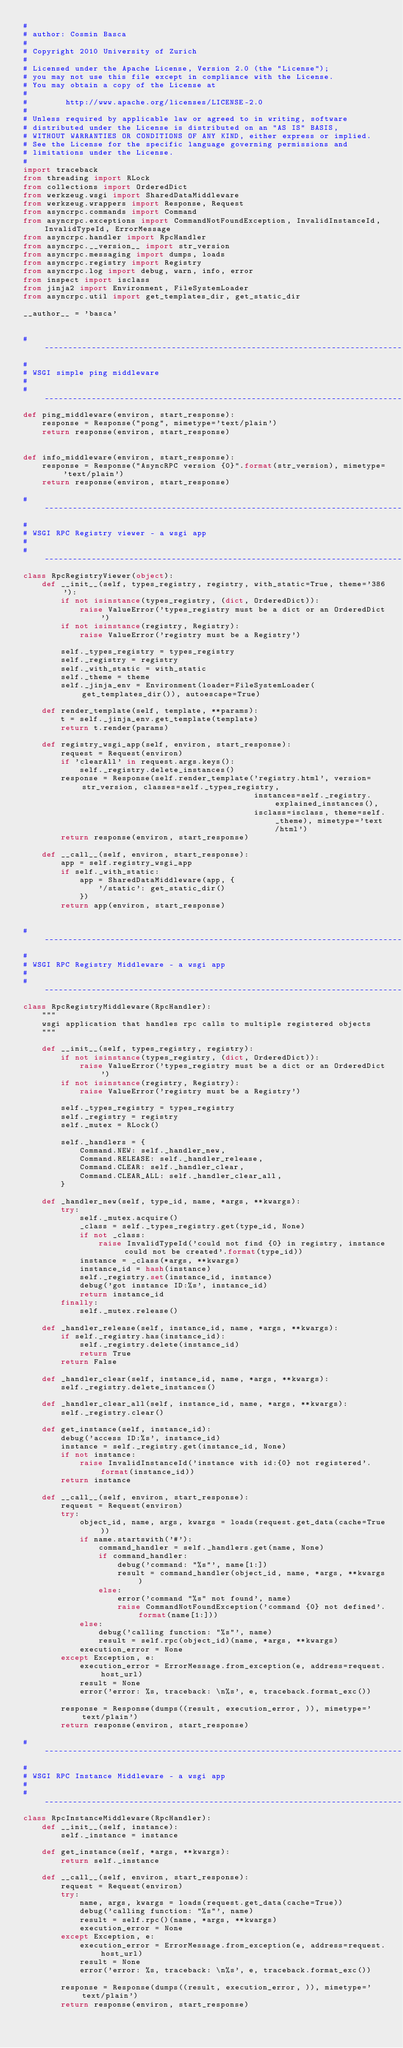<code> <loc_0><loc_0><loc_500><loc_500><_Python_>#
# author: Cosmin Basca
#
# Copyright 2010 University of Zurich
#
# Licensed under the Apache License, Version 2.0 (the "License");
# you may not use this file except in compliance with the License.
# You may obtain a copy of the License at
#
#        http://www.apache.org/licenses/LICENSE-2.0
#
# Unless required by applicable law or agreed to in writing, software
# distributed under the License is distributed on an "AS IS" BASIS,
# WITHOUT WARRANTIES OR CONDITIONS OF ANY KIND, either express or implied.
# See the License for the specific language governing permissions and
# limitations under the License.
#
import traceback
from threading import RLock
from collections import OrderedDict
from werkzeug.wsgi import SharedDataMiddleware
from werkzeug.wrappers import Response, Request
from asyncrpc.commands import Command
from asyncrpc.exceptions import CommandNotFoundException, InvalidInstanceId, InvalidTypeId, ErrorMessage
from asyncrpc.handler import RpcHandler
from asyncrpc.__version__ import str_version
from asyncrpc.messaging import dumps, loads
from asyncrpc.registry import Registry
from asyncrpc.log import debug, warn, info, error
from inspect import isclass
from jinja2 import Environment, FileSystemLoader
from asyncrpc.util import get_templates_dir, get_static_dir

__author__ = 'basca'


# ----------------------------------------------------------------------------------------------------------------------
#
# WSGI simple ping middleware
#
# ----------------------------------------------------------------------------------------------------------------------
def ping_middleware(environ, start_response):
    response = Response("pong", mimetype='text/plain')
    return response(environ, start_response)


def info_middleware(environ, start_response):
    response = Response("AsyncRPC version {0}".format(str_version), mimetype='text/plain')
    return response(environ, start_response)

# ----------------------------------------------------------------------------------------------------------------------
#
# WSGI RPC Registry viewer - a wsgi app
#
# ----------------------------------------------------------------------------------------------------------------------
class RpcRegistryViewer(object):
    def __init__(self, types_registry, registry, with_static=True, theme='386'):
        if not isinstance(types_registry, (dict, OrderedDict)):
            raise ValueError('types_registry must be a dict or an OrderedDict')
        if not isinstance(registry, Registry):
            raise ValueError('registry must be a Registry')

        self._types_registry = types_registry
        self._registry = registry
        self._with_static = with_static
        self._theme = theme
        self._jinja_env = Environment(loader=FileSystemLoader(get_templates_dir()), autoescape=True)

    def render_template(self, template, **params):
        t = self._jinja_env.get_template(template)
        return t.render(params)

    def registry_wsgi_app(self, environ, start_response):
        request = Request(environ)
        if 'clearAll' in request.args.keys():
            self._registry.delete_instances()
        response = Response(self.render_template('registry.html', version=str_version, classes=self._types_registry,
                                                 instances=self._registry.explained_instances(),
                                                 isclass=isclass, theme=self._theme), mimetype='text/html')
        return response(environ, start_response)

    def __call__(self, environ, start_response):
        app = self.registry_wsgi_app
        if self._with_static:
            app = SharedDataMiddleware(app, {
                '/static': get_static_dir()
            })
        return app(environ, start_response)


# ----------------------------------------------------------------------------------------------------------------------
#
# WSGI RPC Registry Middleware - a wsgi app
#
# ----------------------------------------------------------------------------------------------------------------------
class RpcRegistryMiddleware(RpcHandler):
    """
    wsgi application that handles rpc calls to multiple registered objects
    """

    def __init__(self, types_registry, registry):
        if not isinstance(types_registry, (dict, OrderedDict)):
            raise ValueError('types_registry must be a dict or an OrderedDict')
        if not isinstance(registry, Registry):
            raise ValueError('registry must be a Registry')

        self._types_registry = types_registry
        self._registry = registry
        self._mutex = RLock()

        self._handlers = {
            Command.NEW: self._handler_new,
            Command.RELEASE: self._handler_release,
            Command.CLEAR: self._handler_clear,
            Command.CLEAR_ALL: self._handler_clear_all,
        }

    def _handler_new(self, type_id, name, *args, **kwargs):
        try:
            self._mutex.acquire()
            _class = self._types_registry.get(type_id, None)
            if not _class:
                raise InvalidTypeId('could not find {0} in registry, instance could not be created'.format(type_id))
            instance = _class(*args, **kwargs)
            instance_id = hash(instance)
            self._registry.set(instance_id, instance)
            debug('got instance ID:%s', instance_id)
            return instance_id
        finally:
            self._mutex.release()

    def _handler_release(self, instance_id, name, *args, **kwargs):
        if self._registry.has(instance_id):
            self._registry.delete(instance_id)
            return True
        return False

    def _handler_clear(self, instance_id, name, *args, **kwargs):
        self._registry.delete_instances()

    def _handler_clear_all(self, instance_id, name, *args, **kwargs):
        self._registry.clear()

    def get_instance(self, instance_id):
        debug('access ID:%s', instance_id)
        instance = self._registry.get(instance_id, None)
        if not instance:
            raise InvalidInstanceId('instance with id:{0} not registered'.format(instance_id))
        return instance

    def __call__(self, environ, start_response):
        request = Request(environ)
        try:
            object_id, name, args, kwargs = loads(request.get_data(cache=True))
            if name.startswith('#'):
                command_handler = self._handlers.get(name, None)
                if command_handler:
                    debug('command: "%s"', name[1:])
                    result = command_handler(object_id, name, *args, **kwargs)
                else:
                    error('command "%s" not found', name)
                    raise CommandNotFoundException('command {0} not defined'.format(name[1:]))
            else:
                debug('calling function: "%s"', name)
                result = self.rpc(object_id)(name, *args, **kwargs)
            execution_error = None
        except Exception, e:
            execution_error = ErrorMessage.from_exception(e, address=request.host_url)
            result = None
            error('error: %s, traceback: \n%s', e, traceback.format_exc())

        response = Response(dumps((result, execution_error, )), mimetype='text/plain')
        return response(environ, start_response)

# ----------------------------------------------------------------------------------------------------------------------
#
# WSGI RPC Instance Middleware - a wsgi app
#
# ----------------------------------------------------------------------------------------------------------------------
class RpcInstanceMiddleware(RpcHandler):
    def __init__(self, instance):
        self._instance = instance

    def get_instance(self, *args, **kwargs):
        return self._instance

    def __call__(self, environ, start_response):
        request = Request(environ)
        try:
            name, args, kwargs = loads(request.get_data(cache=True))
            debug('calling function: "%s"', name)
            result = self.rpc()(name, *args, **kwargs)
            execution_error = None
        except Exception, e:
            execution_error = ErrorMessage.from_exception(e, address=request.host_url)
            result = None
            error('error: %s, traceback: \n%s', e, traceback.format_exc())

        response = Response(dumps((result, execution_error, )), mimetype='text/plain')
        return response(environ, start_response)</code> 